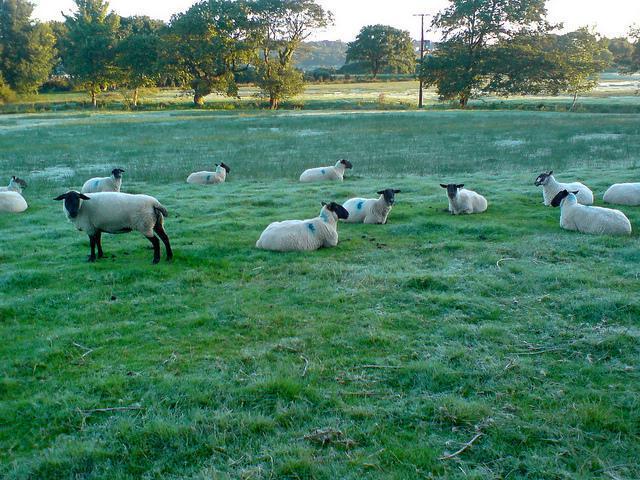How many sheep?
Give a very brief answer. 11. How many sheep are in the picture?
Give a very brief answer. 3. 